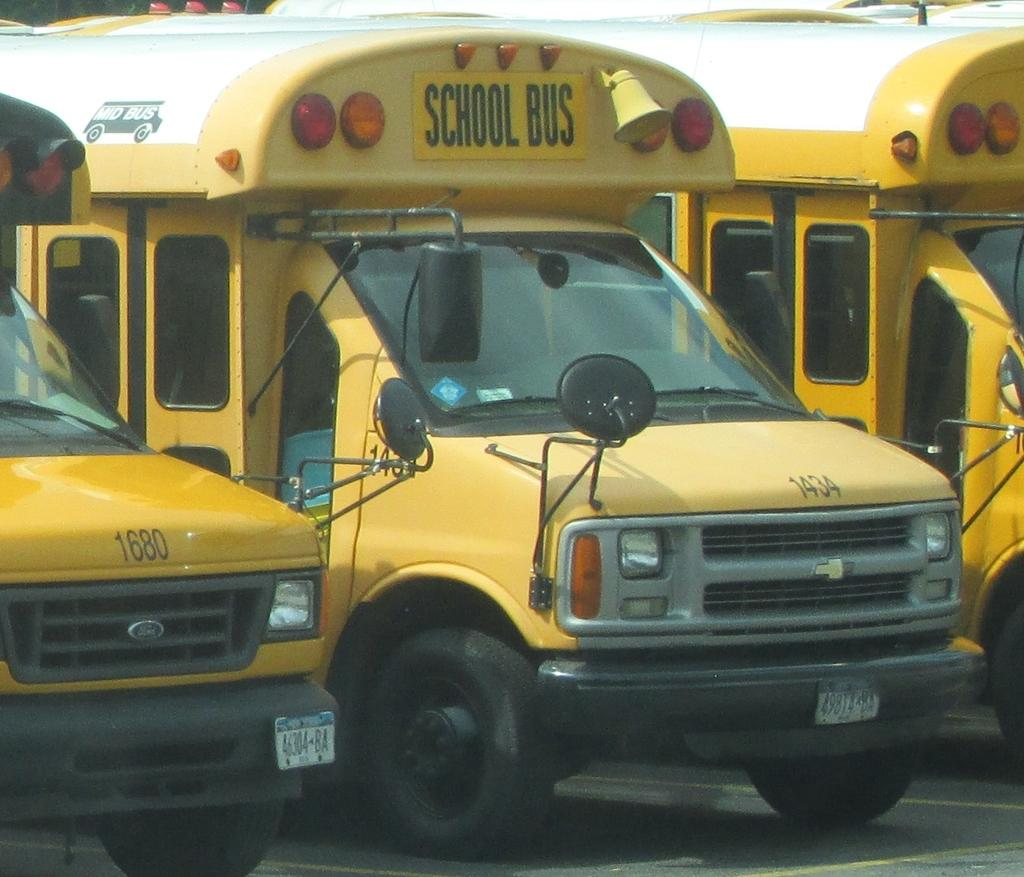<image>
Offer a succinct explanation of the picture presented. a bus with the word school bus at the top 